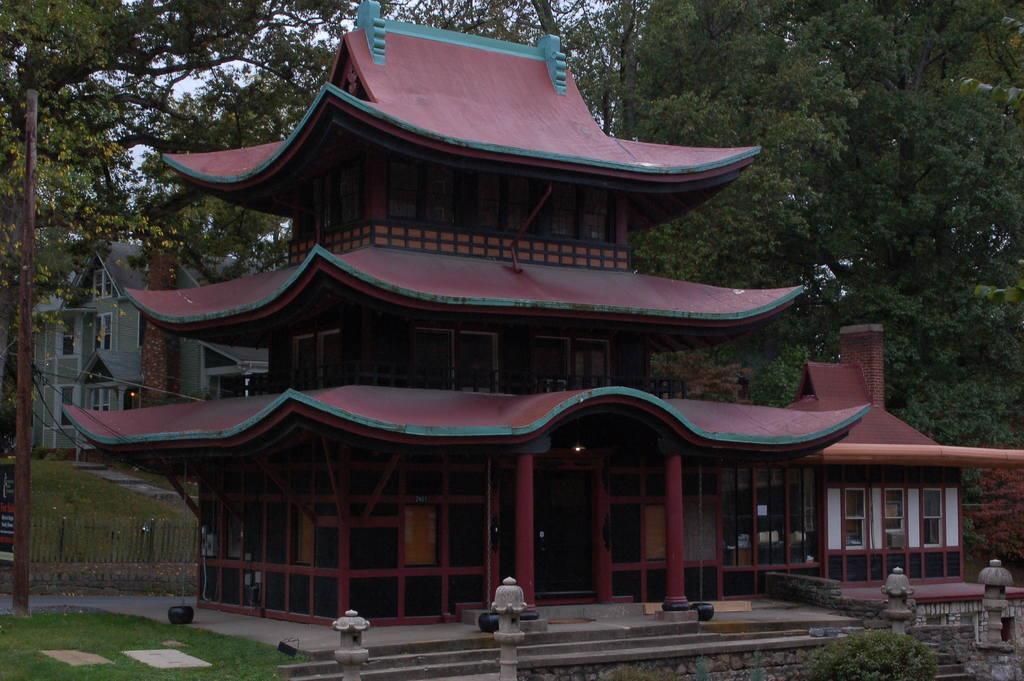In one or two sentences, can you explain what this image depicts? In the middle it is a house which is in red color, in the right side there are green trees. 